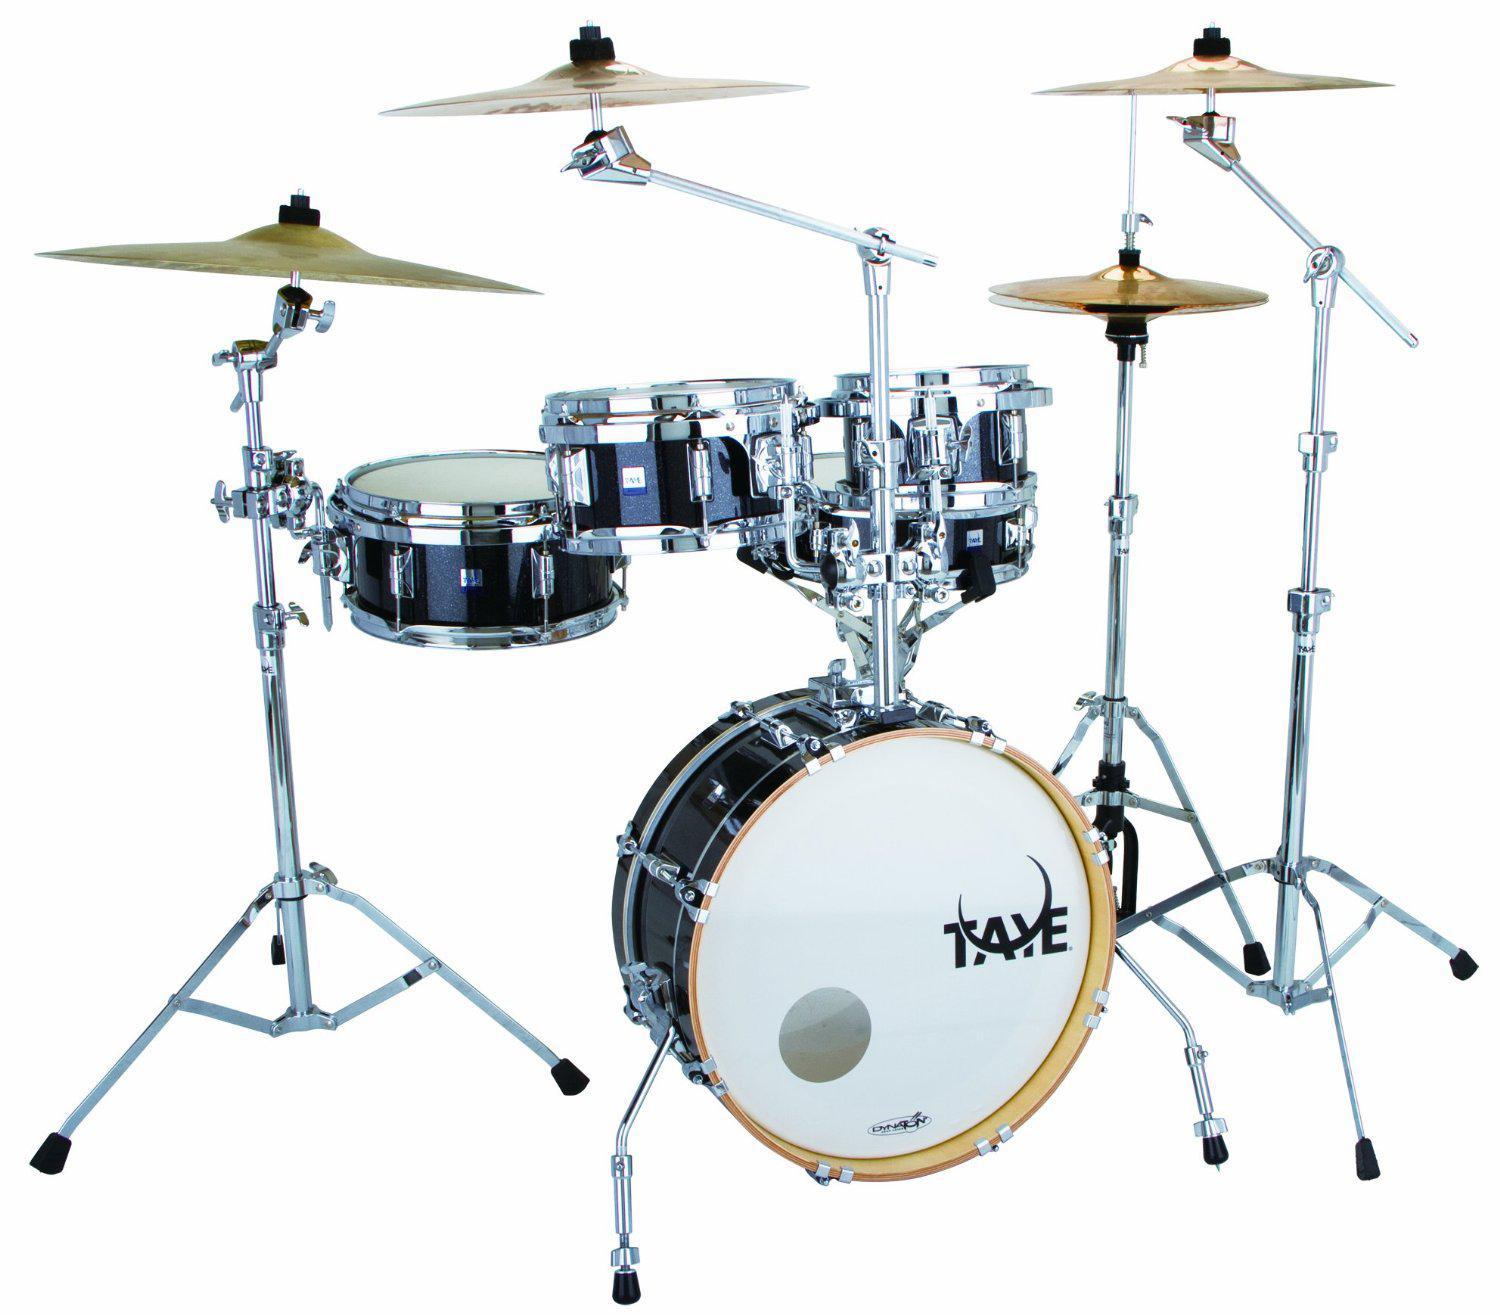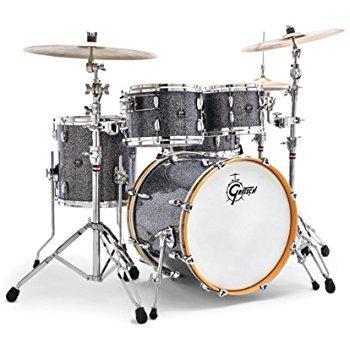The first image is the image on the left, the second image is the image on the right. Examine the images to the left and right. Is the description "A single drum set with a white drumskin appears in each of the images." accurate? Answer yes or no. Yes. The first image is the image on the left, the second image is the image on the right. Assess this claim about the two images: "Each image features a drum kit with exactly one large drum that has a white side facing outwards and is positioned between cymbals on stands.". Correct or not? Answer yes or no. Yes. 